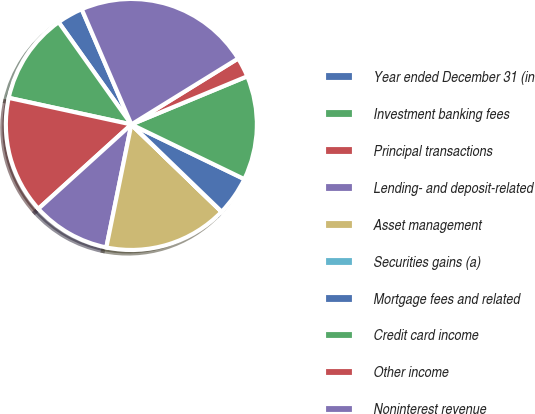Convert chart to OTSL. <chart><loc_0><loc_0><loc_500><loc_500><pie_chart><fcel>Year ended December 31 (in<fcel>Investment banking fees<fcel>Principal transactions<fcel>Lending- and deposit-related<fcel>Asset management<fcel>Securities gains (a)<fcel>Mortgage fees and related<fcel>Credit card income<fcel>Other income<fcel>Noninterest revenue<nl><fcel>3.37%<fcel>11.76%<fcel>15.12%<fcel>10.08%<fcel>15.95%<fcel>0.02%<fcel>5.05%<fcel>13.44%<fcel>2.54%<fcel>22.66%<nl></chart> 